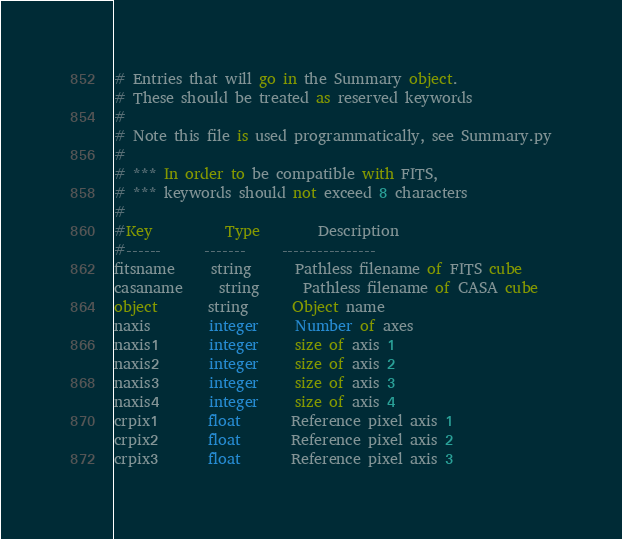<code> <loc_0><loc_0><loc_500><loc_500><_SQL_># Entries that will go in the Summary object.
# These should be treated as reserved keywords
#
# Note this file is used programmatically, see Summary.py
#
# *** In order to be compatible with FITS, 
# *** keywords should not exceed 8 characters 
#
#Key          Type        Description                    
#------      -------     ----------------                
fitsname     string      Pathless filename of FITS cube
casaname     string      Pathless filename of CASA cube
object       string      Object name
naxis        integer     Number of axes
naxis1       integer     size of axis 1
naxis2       integer     size of axis 2
naxis3       integer     size of axis 3
naxis4       integer     size of axis 4
crpix1       float       Reference pixel axis 1
crpix2       float       Reference pixel axis 2
crpix3       float       Reference pixel axis 3</code> 